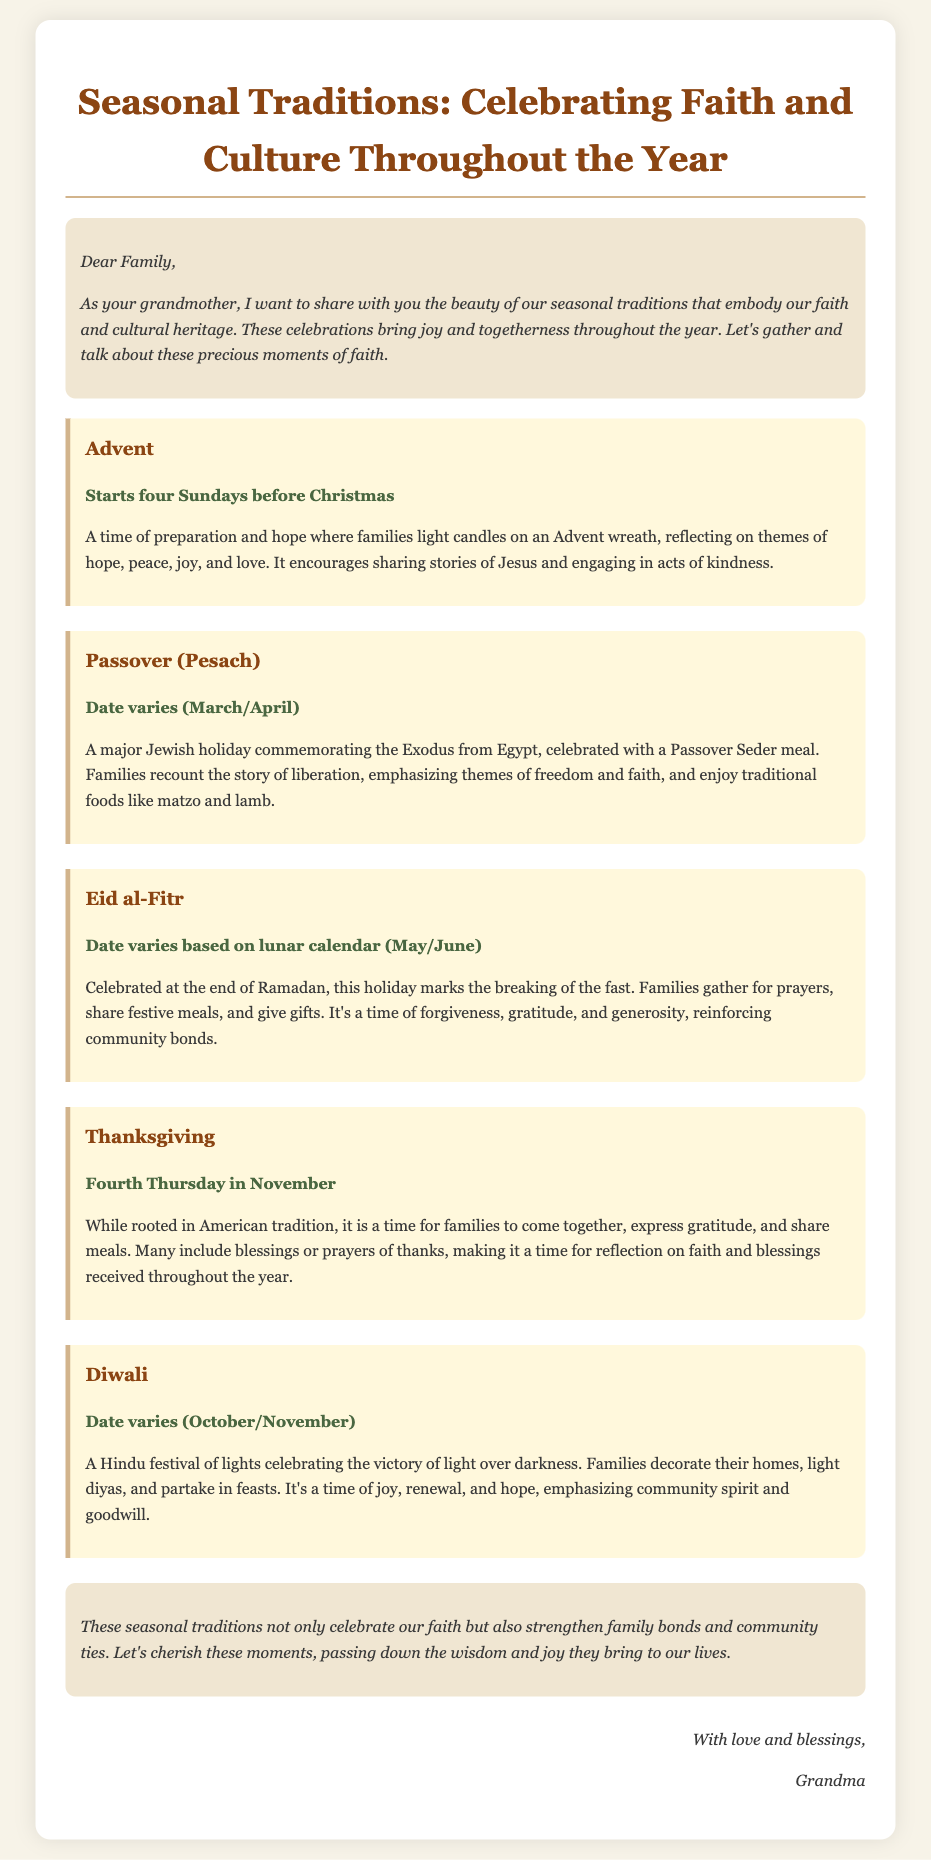what is the title of the memo? The title of the memo is mentioned at the top of the document, summarizing the theme of the seasonal traditions.
Answer: Seasonal Traditions: Celebrating Faith and Culture Throughout the Year how many celebrations are documented? The number of celebrations is listed in the main body of the document under the "celebrations" section.
Answer: Five what holiday marks the end of Ramadan? This information is provided in the description of the celebration related to Ramadan.
Answer: Eid al-Fitr when does Advent begin? The start of Advent is specifically indicated in the document.
Answer: Four Sundays before Christmas what is the significance of Diwali? The document summarizes the reasoning behind celebrating Diwali in its description.
Answer: Victory of light over darkness what is shared during Thanksgiving? The memo discusses the activity families engage in during Thanksgiving celebrations.
Answer: Meals what themes are reflected during Advent? The document lists the themes associated with the Advent celebration.
Answer: Hope, peace, joy, and love what is the format of the Passover meal? The document references the specific event associated with celebrating Passover.
Answer: Passover Seder meal how does the memo conclude? The conclusion section of the memo contains the essential message emphasizing the importance of traditions.
Answer: Cherish these moments who signed the memo? The author's signature is located at the end of the document in the signature section.
Answer: Grandma 